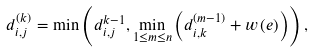Convert formula to latex. <formula><loc_0><loc_0><loc_500><loc_500>d _ { i , j } ^ { ( k ) } = \min \left ( d _ { i , j } ^ { k - 1 } , \underset { 1 \leq m \leq n } { \min } \left ( d _ { i , k } ^ { ( m - 1 ) } + w \left ( e \right ) \right ) \right ) ,</formula> 